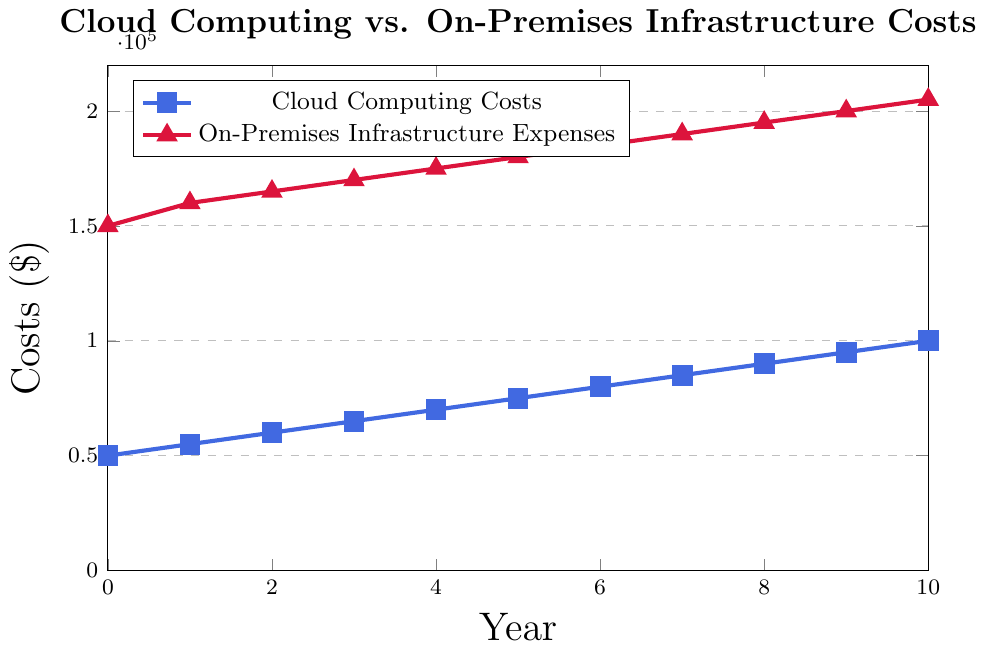What's the difference in costs between Cloud Computing and On-Premises Infrastructure in Year 3? The Cloud Computing cost in Year 3 is $65,000, and the On-Premises Infrastructure cost in Year 3 is $170,000. The difference is $170,000 - $65,000.
Answer: $105,000 Which cost is higher in Year 5, and by how much? In Year 5, the Cloud Computing cost is $75,000, and the On-Premises Infrastructure cost is $180,000. The On-Premises Infrastructure cost is higher. The difference is $180,000 - $75,000.
Answer: On-Premises by $105,000 What is the average cost of Cloud Computing over the 10 years? Adding the Cloud Computing costs from Year 0 to Year 10: ($50,000 + $55,000 + $60,000 + $65,000 + $70,000 + $75,000 + $80,000 + $85,000 + $90,000 + $95,000 + $100,000) = $825,000. Divide by 11 years.
Answer: $75,000 Are Cloud Computing costs increasing at a constant rate? By observing the plot, each consecutive year shows an increase of $5,000 in Cloud Computing costs, indicating a constant rate of increase.
Answer: Yes In which year is the gap between Cloud Computing and On-Premises Infrastructure costs the least? The gap is the least where the difference between On-Premises and Cloud Computing costs is smallest. This is in Year 10 where the difference is $205,000 - $100,000.
Answer: Year 10 By how much did On-Premises Infrastructure expenses increase from Year 0 to Year 10? On-Premises Infrastructure expenses in Year 0 are $150,000 and in Year 10 are $205,000. The difference is $205,000 - $150,000.
Answer: $55,000 What is the percentage increase in Cloud Computing costs from Year 2 to Year 6? The cost in Year 2 is $60,000, and in Year 6 is $80,000. The increase is $80,000 - $60,000 = $20,000. The percentage increase is ($20,000 / $60,000) * 100.
Answer: 33.33% In which year do Cloud Computing costs first reach half of On-Premises Infrastructure expenses? Half of On-Premises expenses in Year 0 is $75,000. Cloud Computing first reaches $75,000 at Year 5.
Answer: Year 5 What is the total cost of On-Premises Infrastructure over the entire 10-year period? Adding the On-Premises Infrastructure expenses from Year 0 to Year 10: ($150,000 + $160,000 + $165,000 + $170,000 + $175,000 + $180,000 + $185,000 + $190,000 + $195,000 + $200,000 + $205,000) = $1,975,000.
Answer: $1,975,000 Visually, which color represents Cloud Computing costs and which represents On-Premises Infrastructure expenses? The Cloud Computing costs are represented by the blue line with square markers, and the On-Premises Infrastructure expenses are represented by the red line with triangle markers.
Answer: Blue for Cloud, Red for On-Premises 